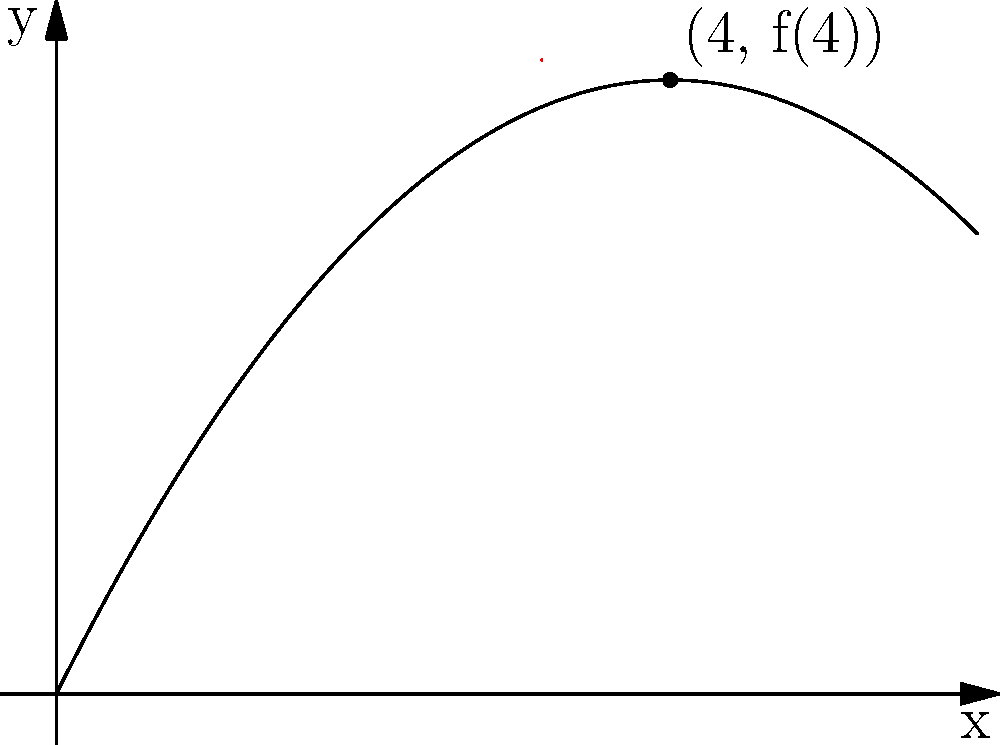In a community outreach program, you're teaching physics to underprivileged students using a projectile motion demonstration. The trajectory of a projectile is modeled by the function $f(x) = -0.25x^2 + 2x$, where $x$ and $y$ are measured in meters. What is the slope of the tangent line to this trajectory at the point where $x = 4$ meters? To find the slope of the tangent line at a specific point, we need to calculate the derivative of the function and evaluate it at the given point. Let's approach this step-by-step:

1) The function is $f(x) = -0.25x^2 + 2x$

2) To find the derivative, we use the power rule:
   $f'(x) = -0.25 \cdot 2x + 2 = -0.5x + 2$

3) We want to find the slope at $x = 4$, so we evaluate $f'(4)$:
   $f'(4) = -0.5(4) + 2 = -2 + 2 = 0$

4) Therefore, the slope of the tangent line at $x = 4$ is 0.

This result means that at $x = 4$ meters, the projectile has reached its maximum height and its vertical velocity is momentarily zero, which is a key concept in projectile motion that can be related to real-world scenarios for the students.
Answer: 0 